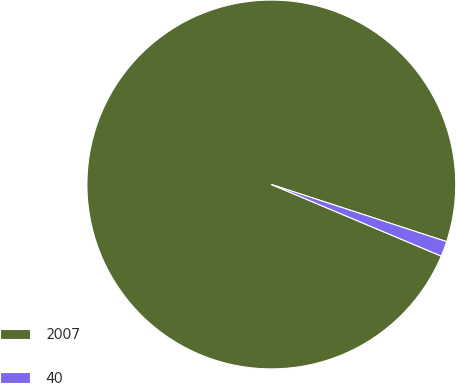<chart> <loc_0><loc_0><loc_500><loc_500><pie_chart><fcel>2007<fcel>40<nl><fcel>98.67%<fcel>1.33%<nl></chart> 